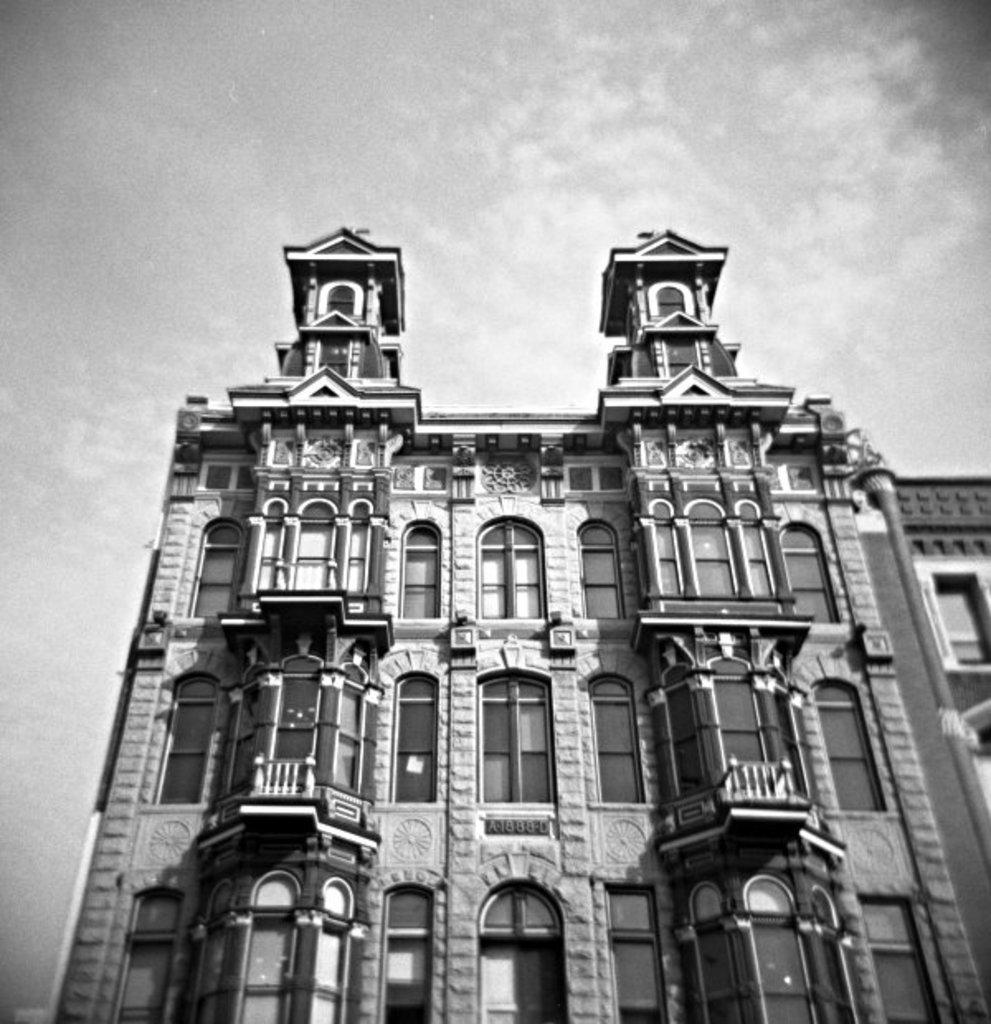What is the color scheme of the image? The image is black and white. What is the main subject of the image? There is a building in the image. What specific feature can be seen on the building? The building has windows. What type of texture can be seen on the hose in the image? There is no hose present in the image, so it is not possible to determine the texture. 